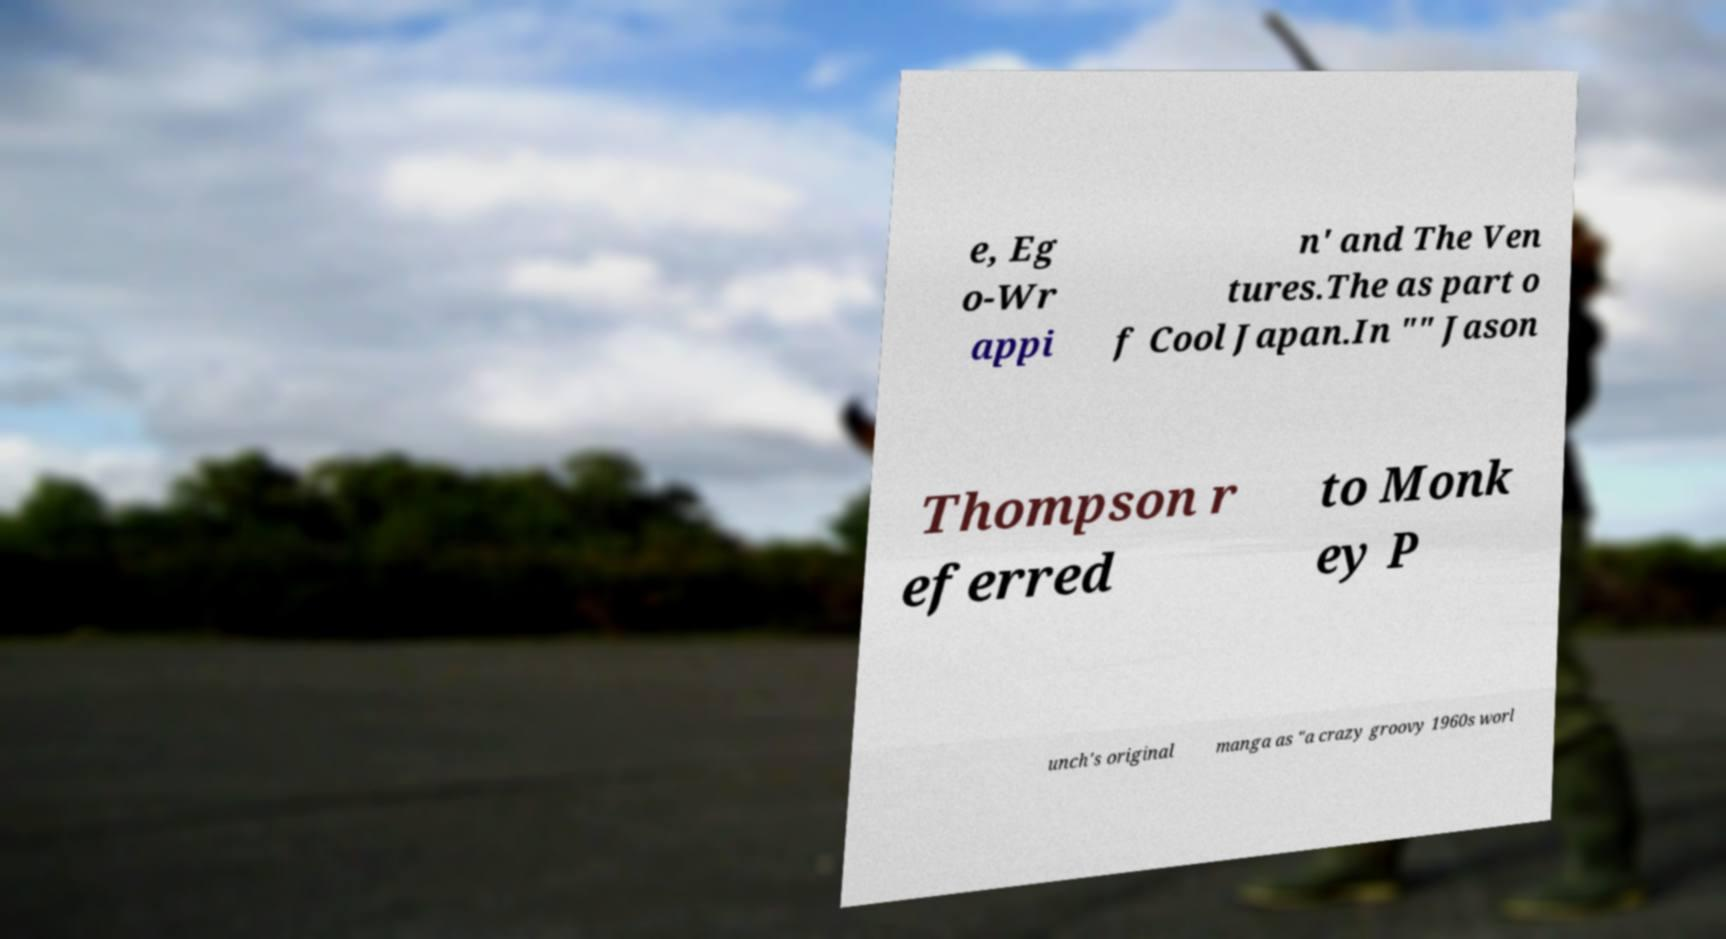For documentation purposes, I need the text within this image transcribed. Could you provide that? e, Eg o-Wr appi n' and The Ven tures.The as part o f Cool Japan.In "" Jason Thompson r eferred to Monk ey P unch's original manga as "a crazy groovy 1960s worl 